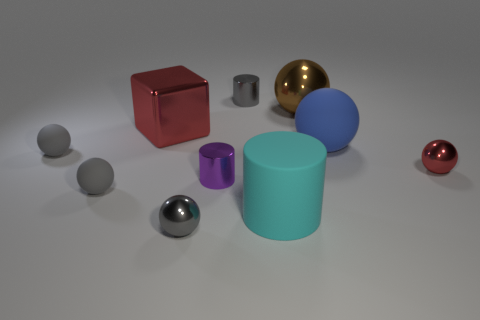There is a big object that is behind the cyan rubber thing and left of the brown metallic ball; what is its shape? The shape of the large object located behind the cyan cylinder and to the left of the brown metallic sphere is a cube. It appears to have a sleek, reflective red surface that distinguishes it clearly from other objects in the surrounding area. 